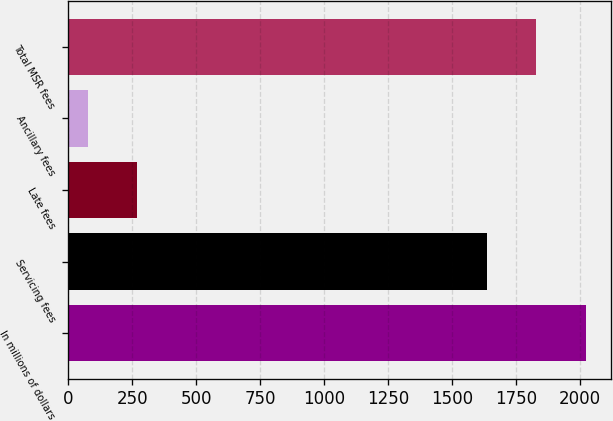<chart> <loc_0><loc_0><loc_500><loc_500><bar_chart><fcel>In millions of dollars<fcel>Servicing fees<fcel>Late fees<fcel>Ancillary fees<fcel>Total MSR fees<nl><fcel>2021.4<fcel>1635<fcel>270.2<fcel>77<fcel>1828.2<nl></chart> 